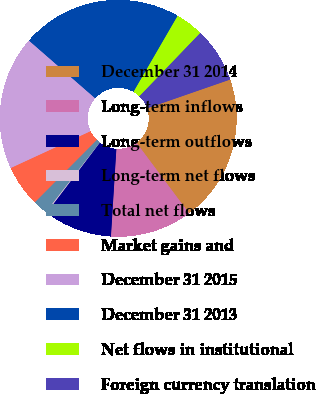<chart> <loc_0><loc_0><loc_500><loc_500><pie_chart><fcel>December 31 2014<fcel>Long-term inflows<fcel>Long-term outflows<fcel>Long-term net flows<fcel>Total net flows<fcel>Market gains and<fcel>December 31 2015<fcel>December 31 2013<fcel>Net flows in institutional<fcel>Foreign currency translation<nl><fcel>20.12%<fcel>11.18%<fcel>9.34%<fcel>0.15%<fcel>1.98%<fcel>5.66%<fcel>18.29%<fcel>21.96%<fcel>3.82%<fcel>7.5%<nl></chart> 